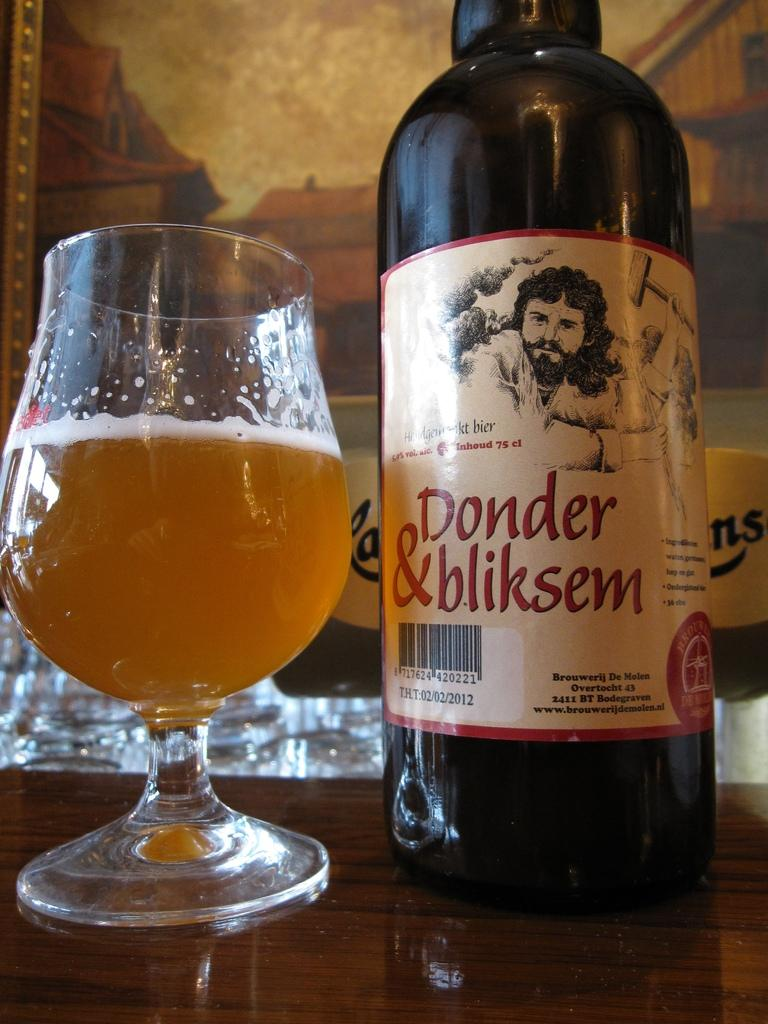What is in the glass that is visible in the image? There is a glass with wine in the image. Where is the glass located in the image? The glass is on a table. What else can be seen related to wine in the image? There is a wine bottle with a label in the image. How is the wine bottle positioned in relation to the glass? The wine bottle is beside the glass. On what surface are both the glass and wine bottle placed? Both the glass and wine bottle are on a table. What type of music is the wren singing in the image? There is no wren or music present in the image. 